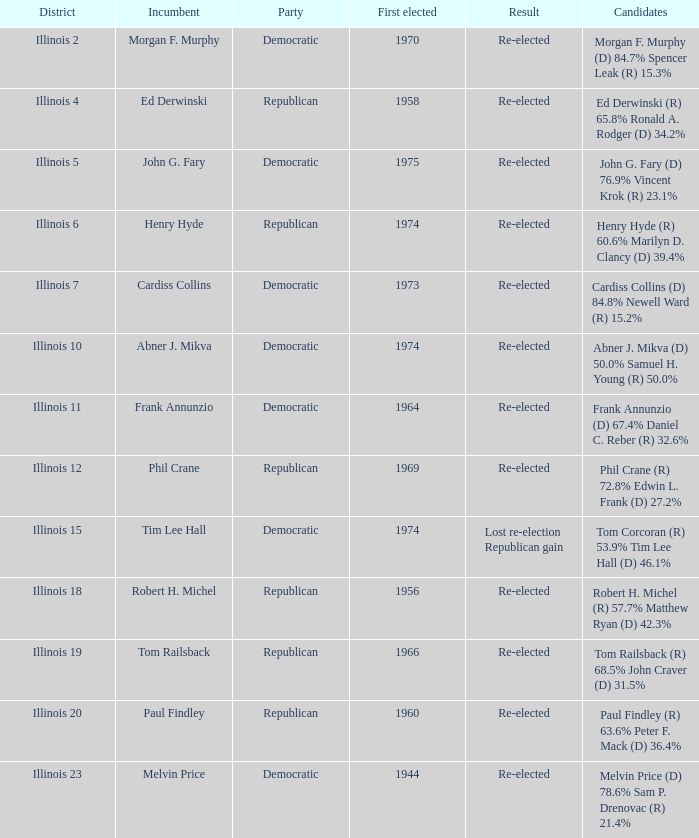In 1944's first-ever election, how many incumbents were there in total? 1.0. 